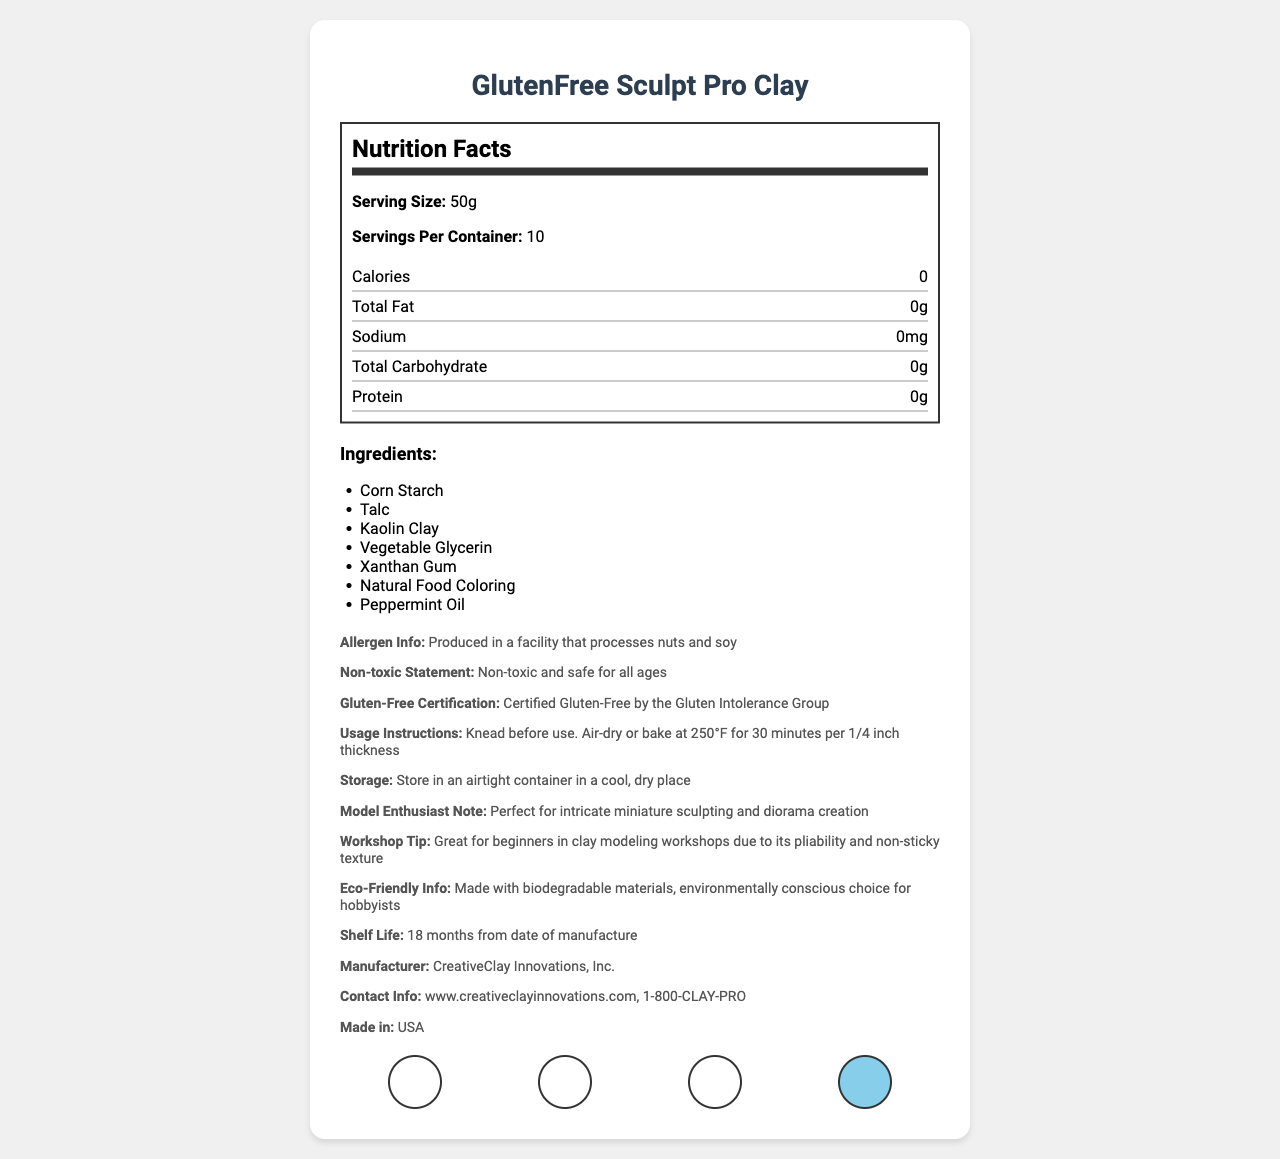what is the serving size for GlutenFree Sculpt Pro Clay? The document specifies that the serving size for GlutenFree Sculpt Pro Clay is 50g.
Answer: 50g how many servings are there per container? The document indicates that there are 10 servings per container of the product.
Answer: 10 list two ingredients in GlutenFree Sculpt Pro Clay. The document lists Corn Starch and Talc as ingredients in GlutenFree Sculpt Pro Clay.
Answer: Corn Starch, Talc is the GlutenFree Sculpt Pro Clay product certified gluten-free? The document confirms that the product is Certified Gluten-Free by the Gluten Intolerance Group.
Answer: Yes how should GlutenFree Sculpt Pro Clay be stored? The storage instructions in the document state that the clay should be kept in an airtight container in a cool, dry place.
Answer: In an airtight container in a cool, dry place what is the shelf life of GlutenFree Sculpt Pro Clay? The document specifies that the shelf life of the product is 18 months from the date of manufacture.
Answer: 18 months from date of manufacture what is one usage instruction for the clay? A. Bake at 350°F B. Air-dry or bake at 250°F C. Microwave for 5 minutes The document states that one usage instruction is to air-dry or bake at 250°F for 30 minutes per 1/4 inch thickness.
Answer: B which of the following is NOT an ingredient in GlutenFree Sculpt Pro Clay? A. Vegetable Glycerin B. Natural Food Coloring C. Wheat Flour Wheat Flour is not listed as an ingredient in the document.
Answer: C is the clay non-toxic? The document includes a non-toxic statement indicating that the clay is non-toxic and safe for all ages.
Answer: Yes what is the main purpose of the document? The document presents comprehensive information about the product, emphasizing its safety, gluten-free certification, and suitability for modeling.
Answer: To provide detailed information about the GlutenFree Sculpt Pro Clay product, including its ingredients, nutrition facts, usage instructions, and additional notes relevant to model enthusiasts and eco-friendly considerations. what is the expiration date of the GlutenFree Sculpt Pro Clay if manufactured in January 2023? The document provides the shelf life as 18 months but does not offer a specific manufacture date, so the exact expiration date is not available.
Answer: Cannot be determined 